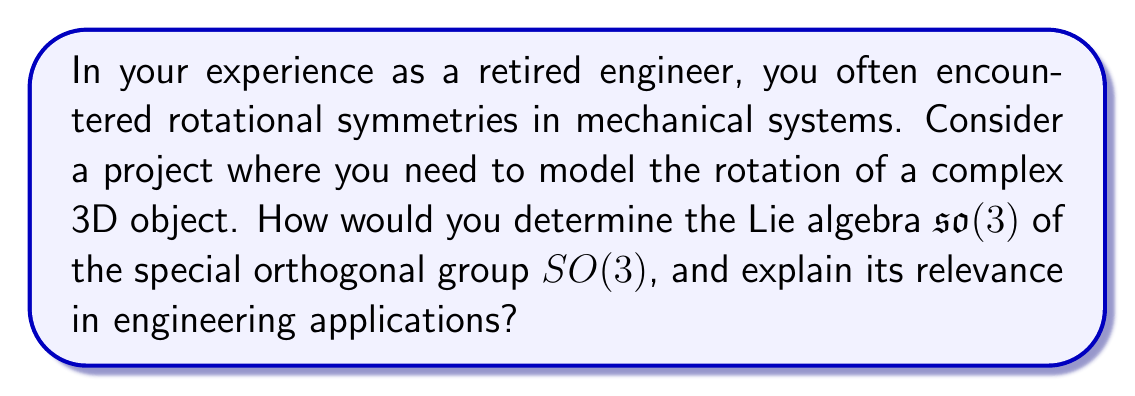Teach me how to tackle this problem. To determine the Lie algebra $\mathfrak{so}(3)$ of $SO(3)$, we follow these steps:

1) Recall that $SO(3)$ consists of 3x3 orthogonal matrices with determinant 1:

   $SO(3) = \{R \in GL(3,\mathbb{R}) : R^TR = I, \det(R) = 1\}$

2) The Lie algebra $\mathfrak{so}(3)$ consists of matrices $X$ such that $e^{tX} \in SO(3)$ for all real $t$.

3) Differentiating $e^{tX}(e^{tX})^T = I$ at $t=0$, we get:

   $X + X^T = 0$

4) This means $X$ must be a 3x3 skew-symmetric matrix:

   $$X = \begin{pmatrix}
   0 & -a & b \\
   a & 0 & -c \\
   -b & c & 0
   \end{pmatrix}$$

5) Therefore, $\mathfrak{so}(3)$ is the space of 3x3 skew-symmetric matrices.

6) We can represent any element of $\mathfrak{so}(3)$ using three parameters $(a,b,c)$, corresponding to rotations around the x, y, and z axes respectively.

In engineering applications, particularly in robotics and computer graphics, $\mathfrak{so}(3)$ is crucial for:

a) Representing angular velocities: The parameters $(a,b,c)$ correspond directly to angular velocities around each axis.

b) Calculating smooth rotations: Using the exponential map $e^{tX}$, we can generate smooth rotational motions.

c) Interpolation between rotations: Lie algebra elements can be easily interpolated, allowing for smooth transitions between different orientations.

d) Optimization problems: Many optimization algorithms in robotics work more efficiently in the Lie algebra space than directly with rotation matrices.
Answer: The Lie algebra $\mathfrak{so}(3)$ of $SO(3)$ is the space of 3x3 skew-symmetric matrices of the form:

$$X = \begin{pmatrix}
0 & -a & b \\
a & 0 & -c \\
-b & c & 0
\end{pmatrix}$$

where $a$, $b$, and $c$ are real numbers. This representation is crucial in engineering for modeling angular velocities, calculating smooth rotations, interpolating between orientations, and solving optimization problems in 3D space. 